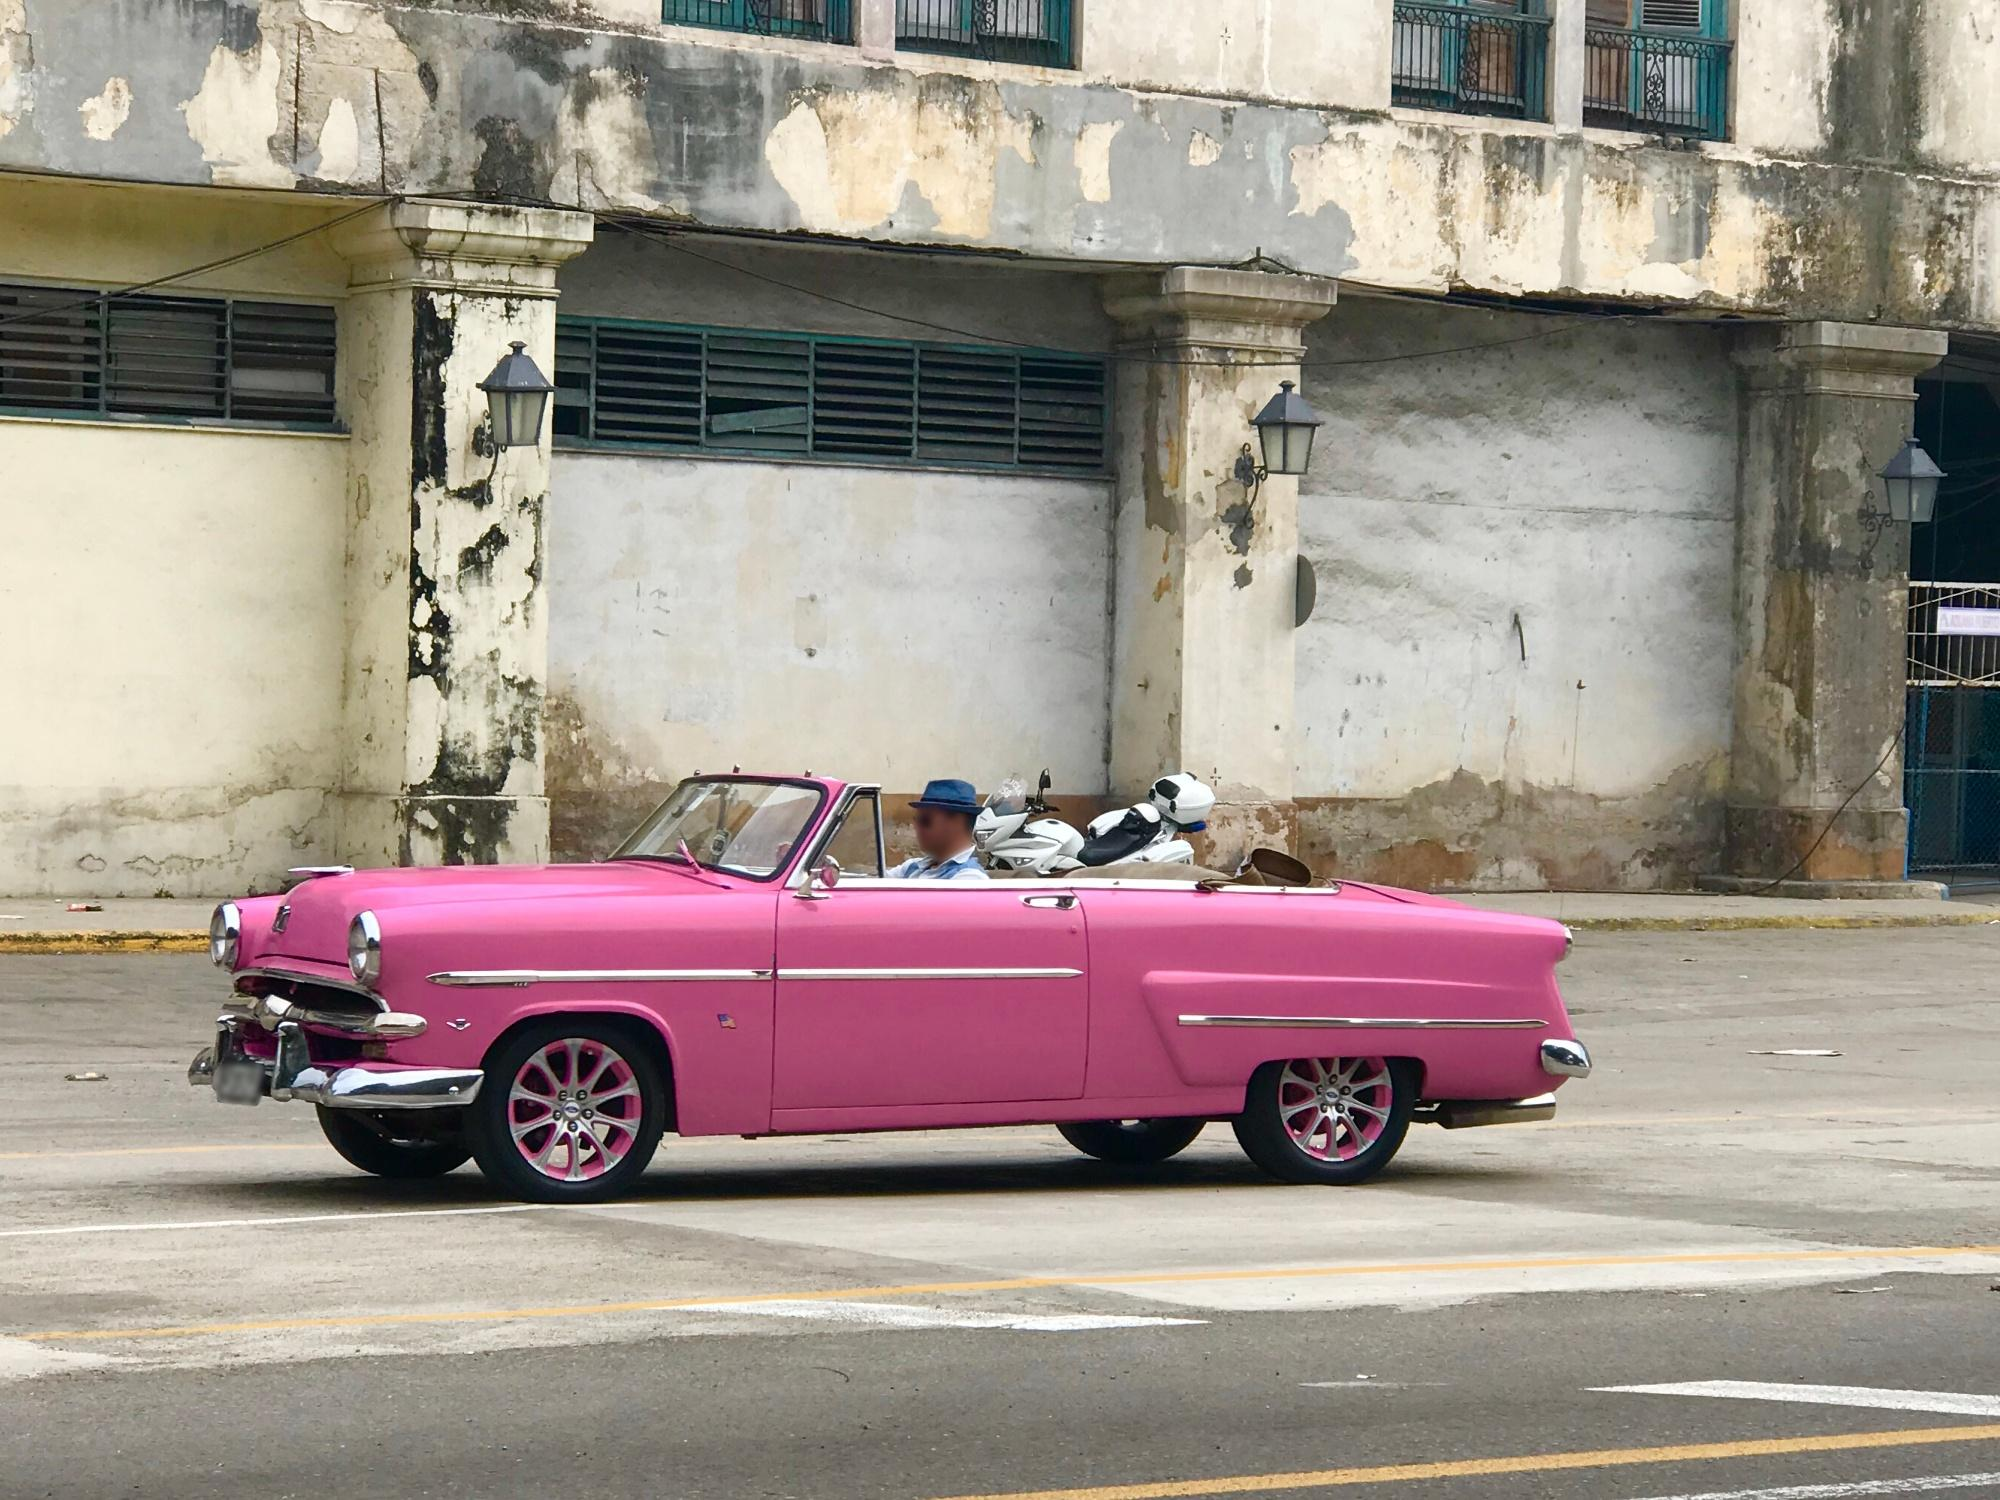How does the condition of the vintage car contrast with the surrounding environment? The well-restored, brightly colored car contrasts sharply with the surrounding area which is characterized by decay and neglect. The car’s vibrant pink hue and shiny details stand out against the dull, weathered textures of the building behind it, reflecting a juxtaposition of preservation and deterioration. 